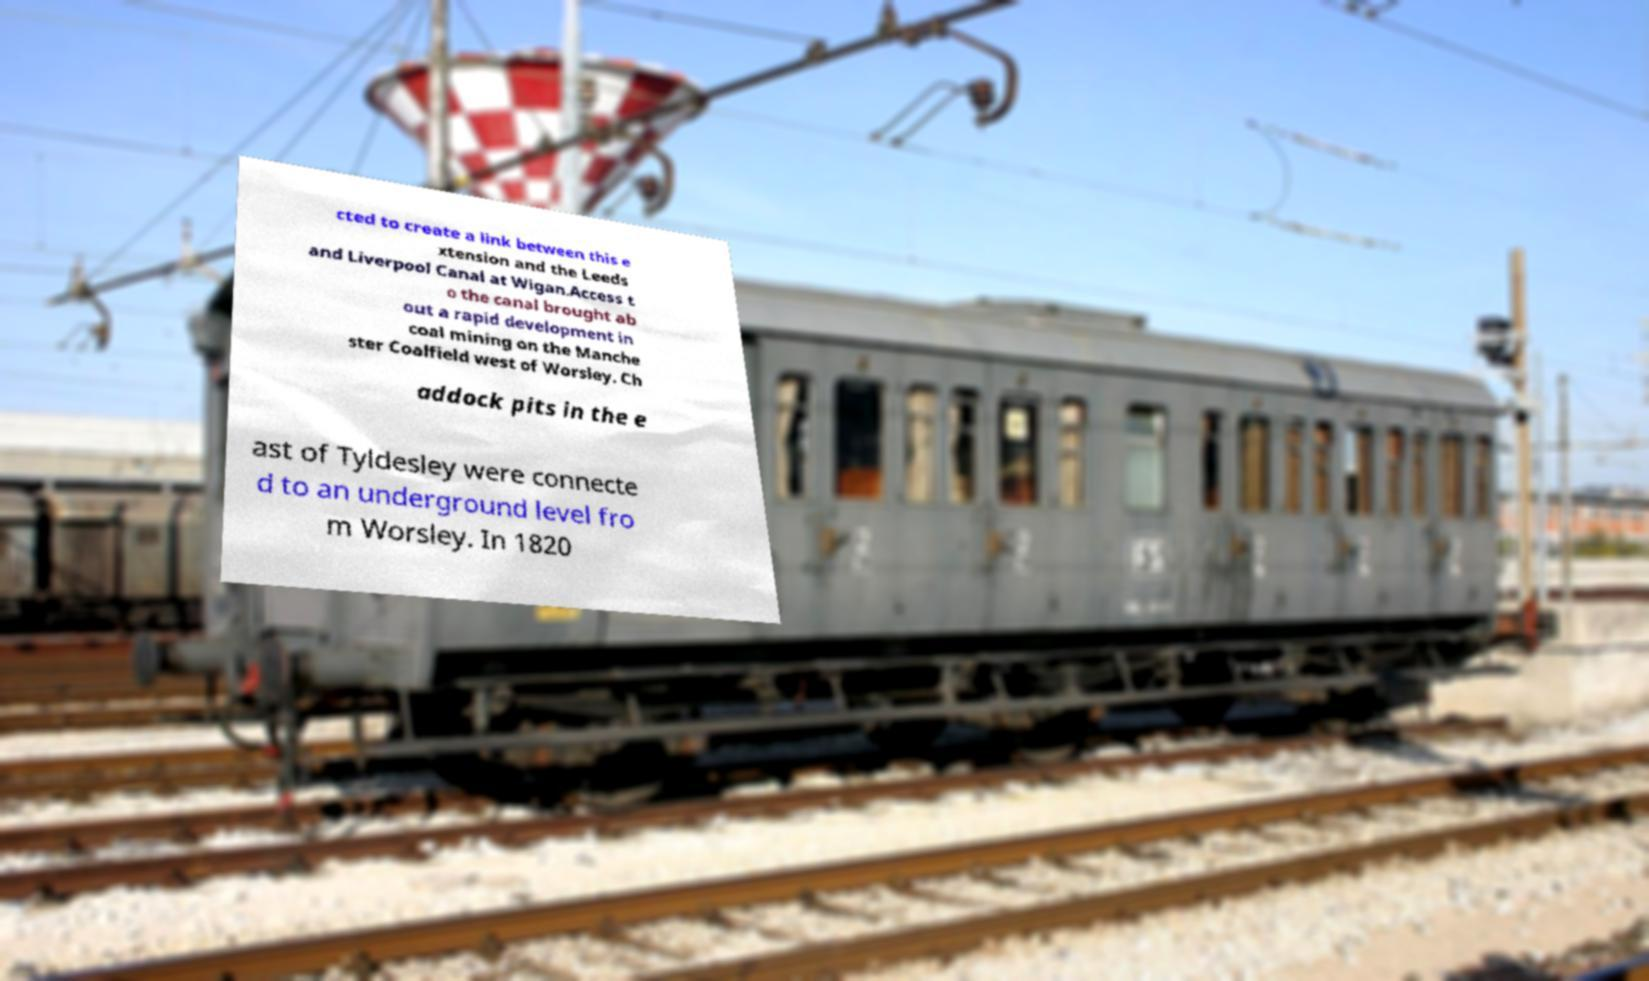For documentation purposes, I need the text within this image transcribed. Could you provide that? cted to create a link between this e xtension and the Leeds and Liverpool Canal at Wigan.Access t o the canal brought ab out a rapid development in coal mining on the Manche ster Coalfield west of Worsley. Ch addock pits in the e ast of Tyldesley were connecte d to an underground level fro m Worsley. In 1820 